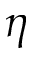<formula> <loc_0><loc_0><loc_500><loc_500>\eta</formula> 